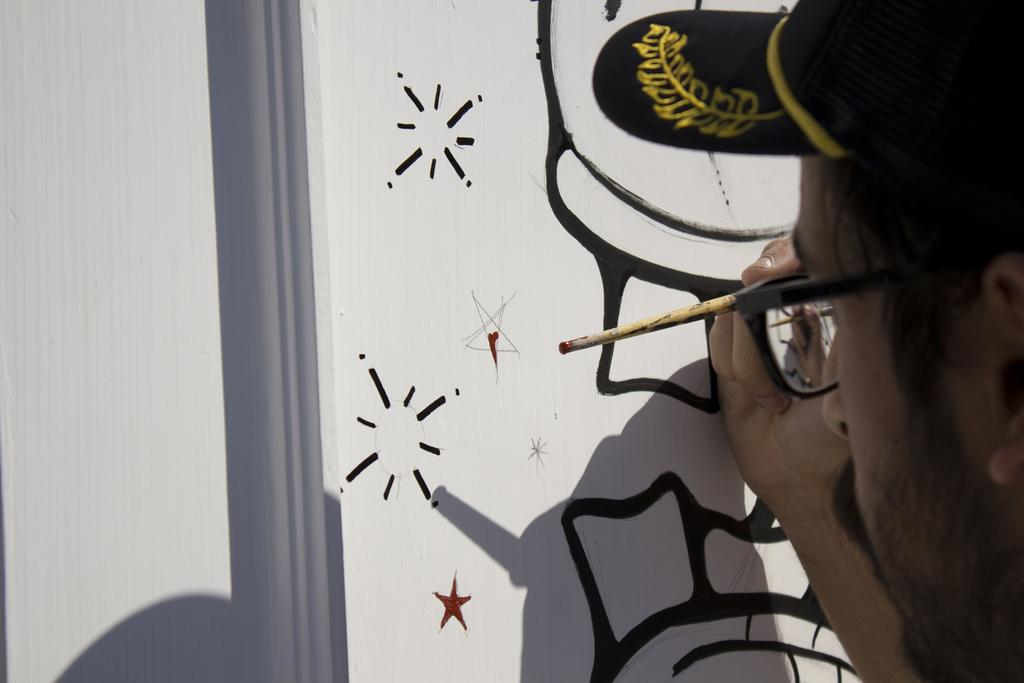Who is present in the image? There is a man in the image. What is the man holding in the image? The man is holding a paint brush. What accessories is the man wearing in the image? The man is wearing a hat and spectacles. What is the man working on in the image? There is a painting on a white color surface in the image, which suggests the man is working on it. How many bikes are parked on the ground in the image? There are no bikes or ground visible in the image; it features a man holding a paint brush and working on a painting. 